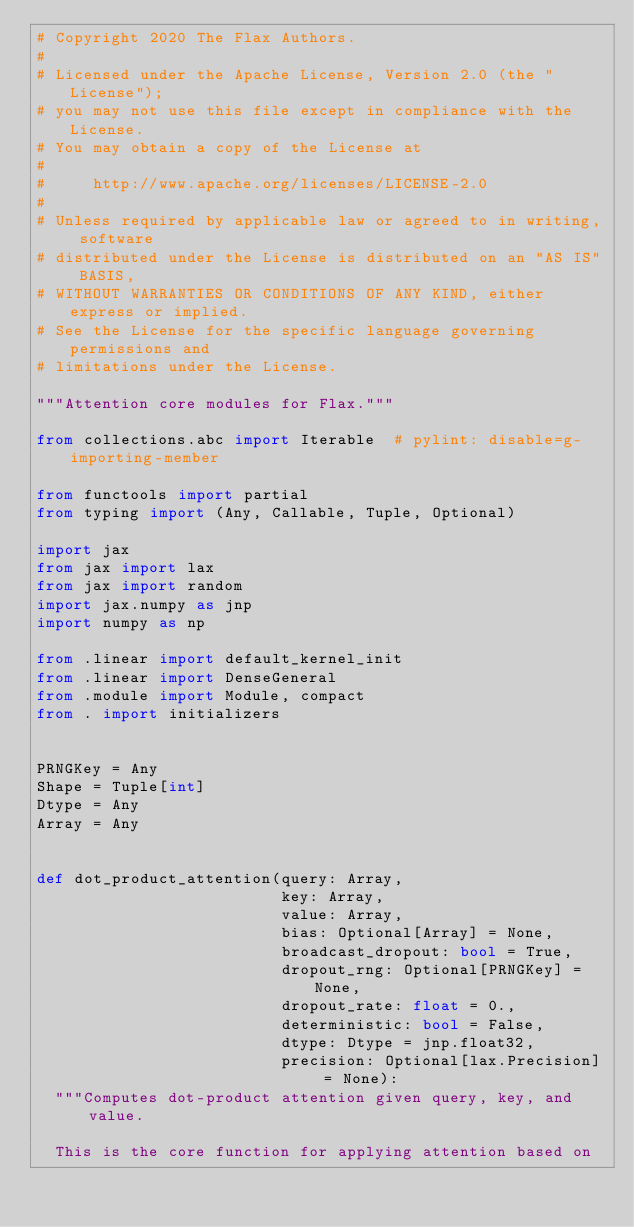<code> <loc_0><loc_0><loc_500><loc_500><_Python_># Copyright 2020 The Flax Authors.
#
# Licensed under the Apache License, Version 2.0 (the "License");
# you may not use this file except in compliance with the License.
# You may obtain a copy of the License at
#
#     http://www.apache.org/licenses/LICENSE-2.0
#
# Unless required by applicable law or agreed to in writing, software
# distributed under the License is distributed on an "AS IS" BASIS,
# WITHOUT WARRANTIES OR CONDITIONS OF ANY KIND, either express or implied.
# See the License for the specific language governing permissions and
# limitations under the License.

"""Attention core modules for Flax."""

from collections.abc import Iterable  # pylint: disable=g-importing-member

from functools import partial
from typing import (Any, Callable, Tuple, Optional)

import jax
from jax import lax
from jax import random
import jax.numpy as jnp
import numpy as np

from .linear import default_kernel_init
from .linear import DenseGeneral
from .module import Module, compact
from . import initializers


PRNGKey = Any
Shape = Tuple[int]
Dtype = Any
Array = Any


def dot_product_attention(query: Array,
                          key: Array,
                          value: Array,
                          bias: Optional[Array] = None,
                          broadcast_dropout: bool = True,
                          dropout_rng: Optional[PRNGKey] = None,
                          dropout_rate: float = 0.,
                          deterministic: bool = False,
                          dtype: Dtype = jnp.float32,
                          precision: Optional[lax.Precision] = None):
  """Computes dot-product attention given query, key, and value.

  This is the core function for applying attention based on</code> 